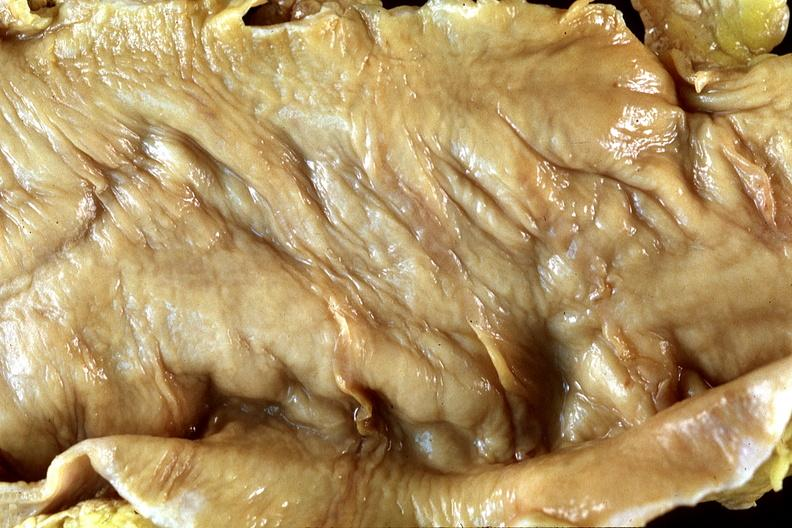what is present?
Answer the question using a single word or phrase. Gastrointestinal 